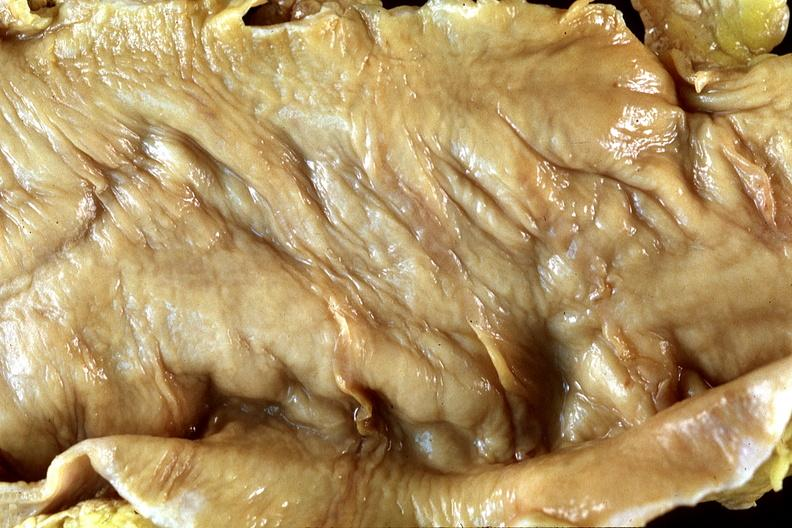what is present?
Answer the question using a single word or phrase. Gastrointestinal 